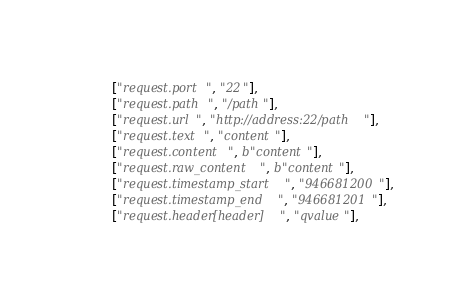<code> <loc_0><loc_0><loc_500><loc_500><_Python_>        ["request.port", "22"],
        ["request.path", "/path"],
        ["request.url", "http://address:22/path"],
        ["request.text", "content"],
        ["request.content", b"content"],
        ["request.raw_content", b"content"],
        ["request.timestamp_start", "946681200"],
        ["request.timestamp_end", "946681201"],
        ["request.header[header]", "qvalue"],
</code> 